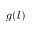Convert formula to latex. <formula><loc_0><loc_0><loc_500><loc_500>g ( l )</formula> 